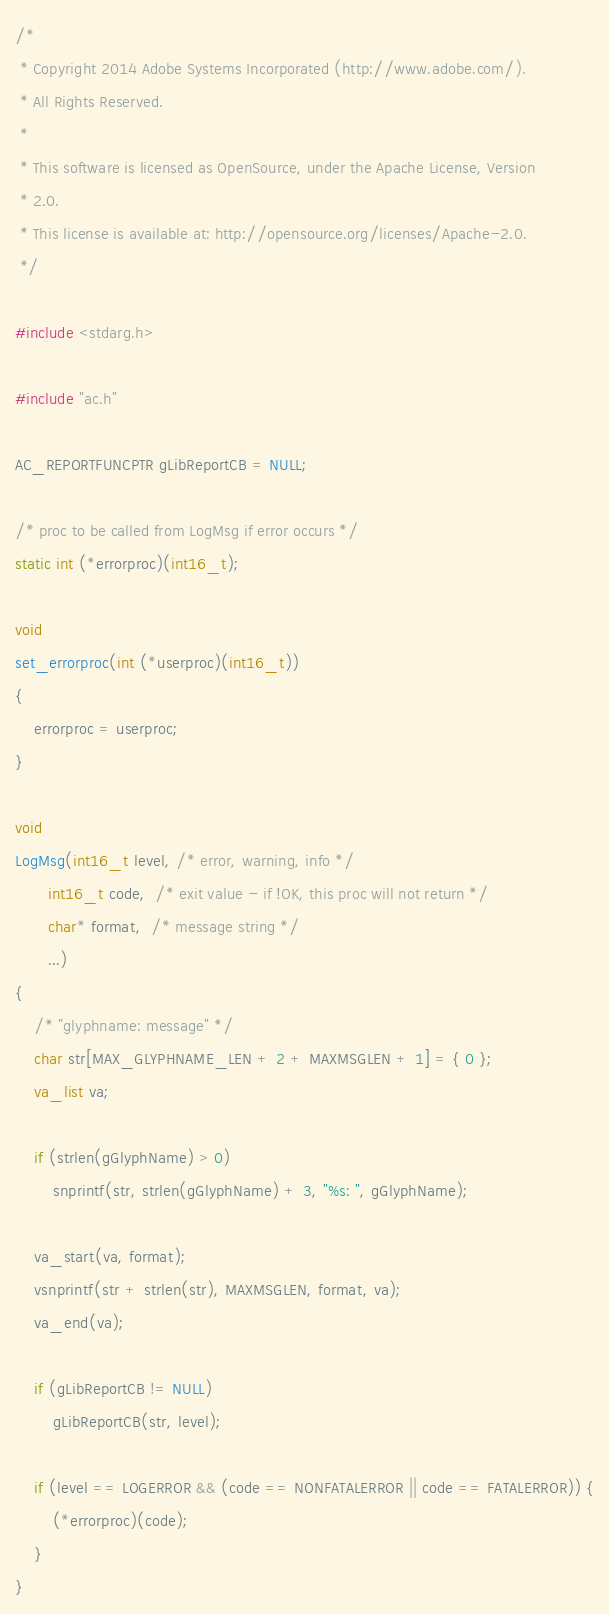<code> <loc_0><loc_0><loc_500><loc_500><_C_>/*
 * Copyright 2014 Adobe Systems Incorporated (http://www.adobe.com/).
 * All Rights Reserved.
 *
 * This software is licensed as OpenSource, under the Apache License, Version
 * 2.0.
 * This license is available at: http://opensource.org/licenses/Apache-2.0.
 */

#include <stdarg.h>

#include "ac.h"

AC_REPORTFUNCPTR gLibReportCB = NULL;

/* proc to be called from LogMsg if error occurs */
static int (*errorproc)(int16_t);

void
set_errorproc(int (*userproc)(int16_t))
{
    errorproc = userproc;
}

void
LogMsg(int16_t level, /* error, warning, info */
       int16_t code,  /* exit value - if !OK, this proc will not return */
       char* format,  /* message string */
       ...)
{
    /* "glyphname: message" */
    char str[MAX_GLYPHNAME_LEN + 2 + MAXMSGLEN + 1] = { 0 };
    va_list va;

    if (strlen(gGlyphName) > 0)
        snprintf(str, strlen(gGlyphName) + 3, "%s: ", gGlyphName);

    va_start(va, format);
    vsnprintf(str + strlen(str), MAXMSGLEN, format, va);
    va_end(va);

    if (gLibReportCB != NULL)
        gLibReportCB(str, level);

    if (level == LOGERROR && (code == NONFATALERROR || code == FATALERROR)) {
        (*errorproc)(code);
    }
}
</code> 